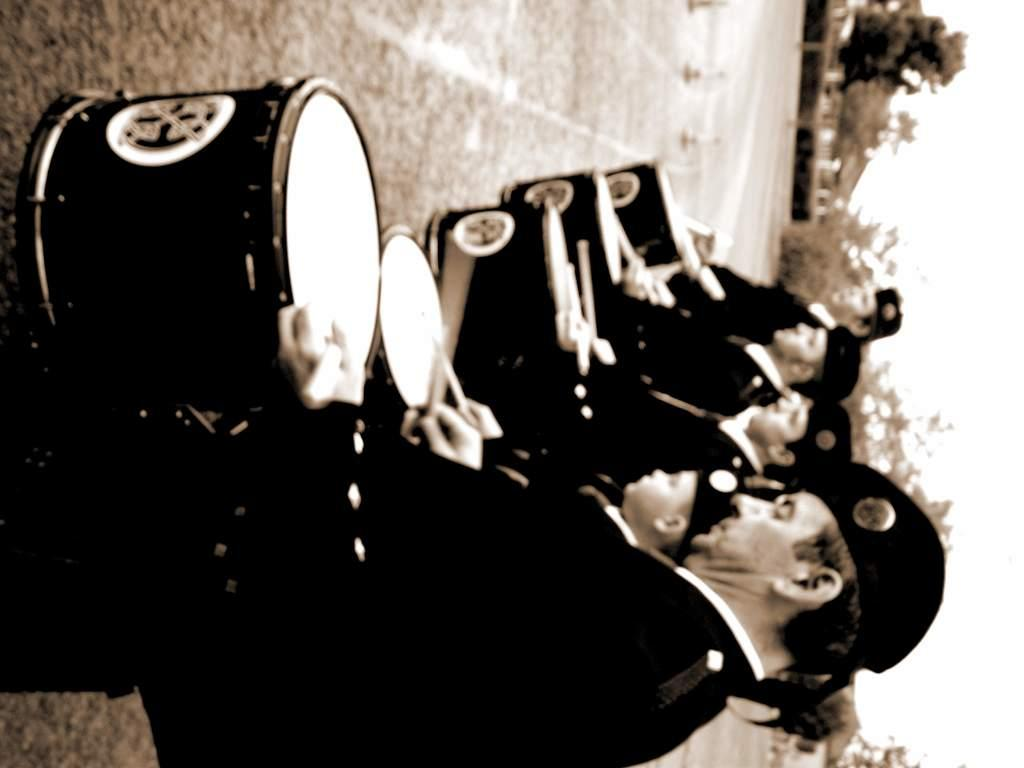What are the people in the image doing? The people in the image are holding drums and sticks. What are the people wearing on their heads? The people are wearing caps. What is visible beneath the people's feet in the image? There is ground visible in the image. What can be seen in the distance behind the people? There are trees and the sky visible in the background of the image. What type of balloon is being used to create the rainstorm in the image? There is no balloon or rainstorm present in the image. What is the reason behind the people playing drums in the image? The provided facts do not give any information about the reason behind the people playing drums. 